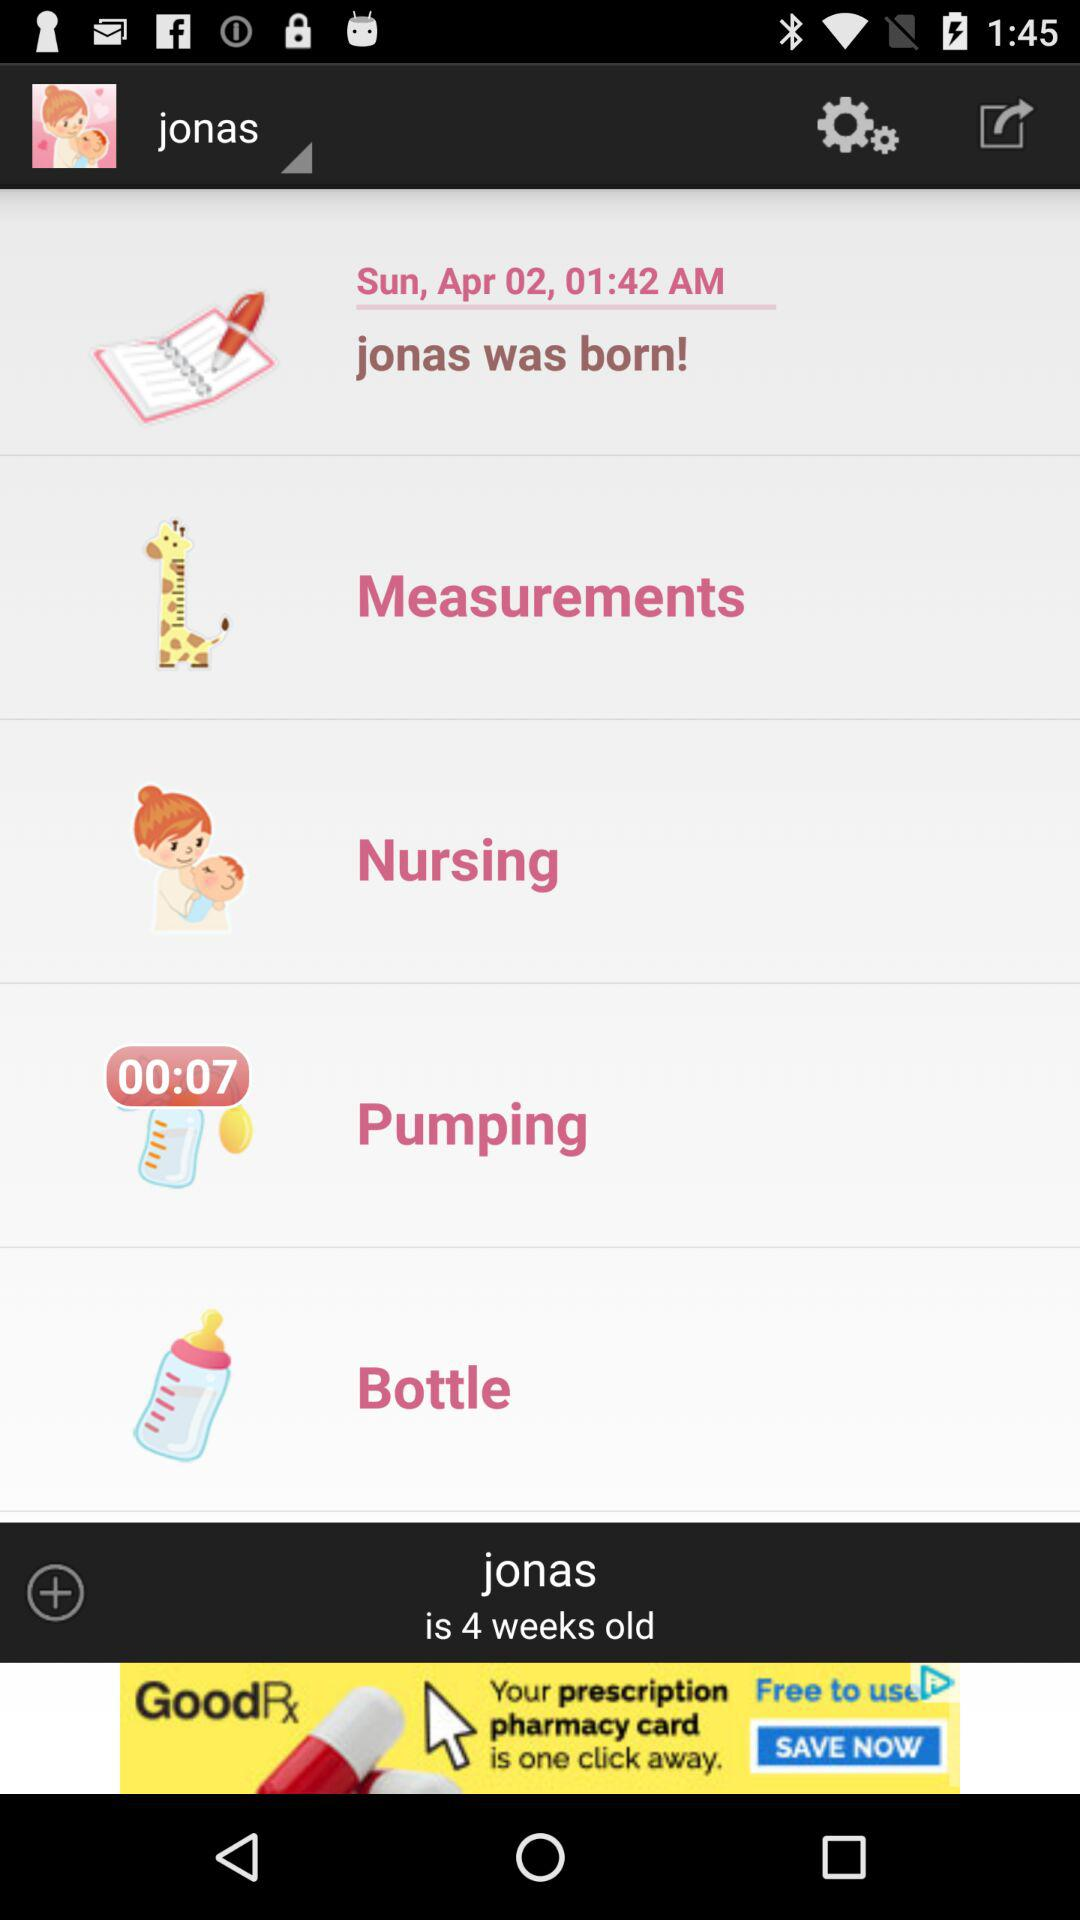How old is Jonas? Jonas is 4 weeks old. 